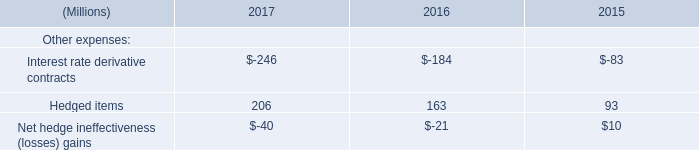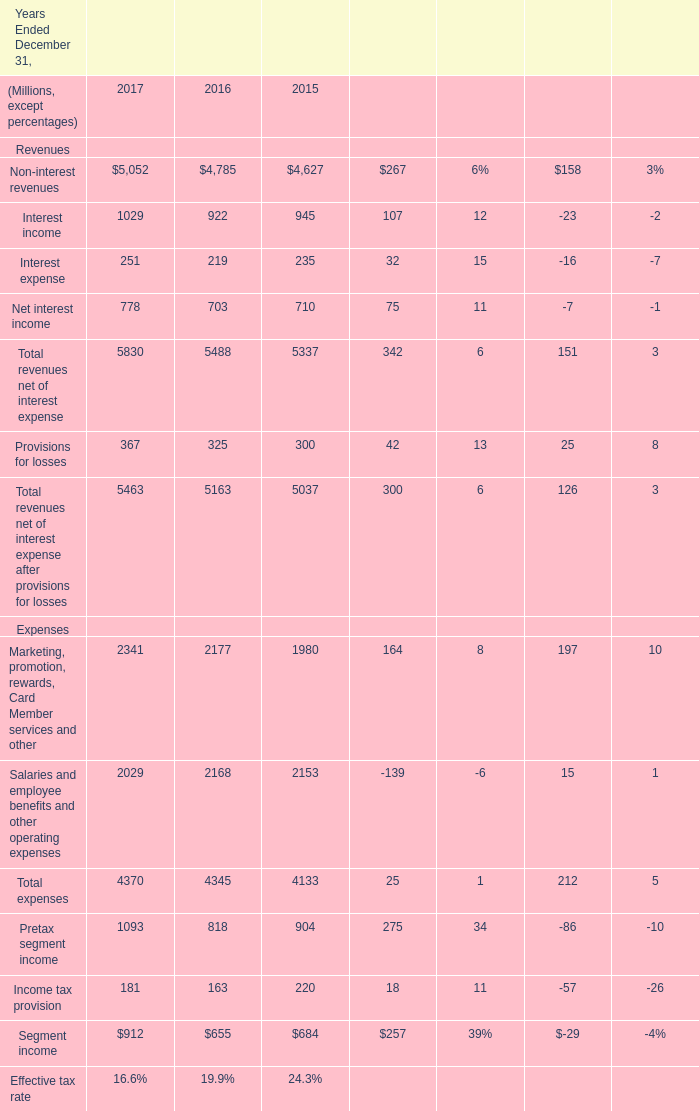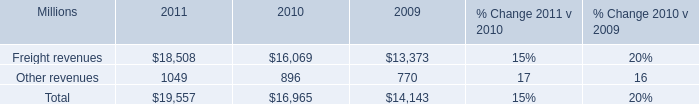fuel surcharge programs represented what share of revenue in 2010? 
Computations: (16965 / 1000)
Answer: 16.965. 